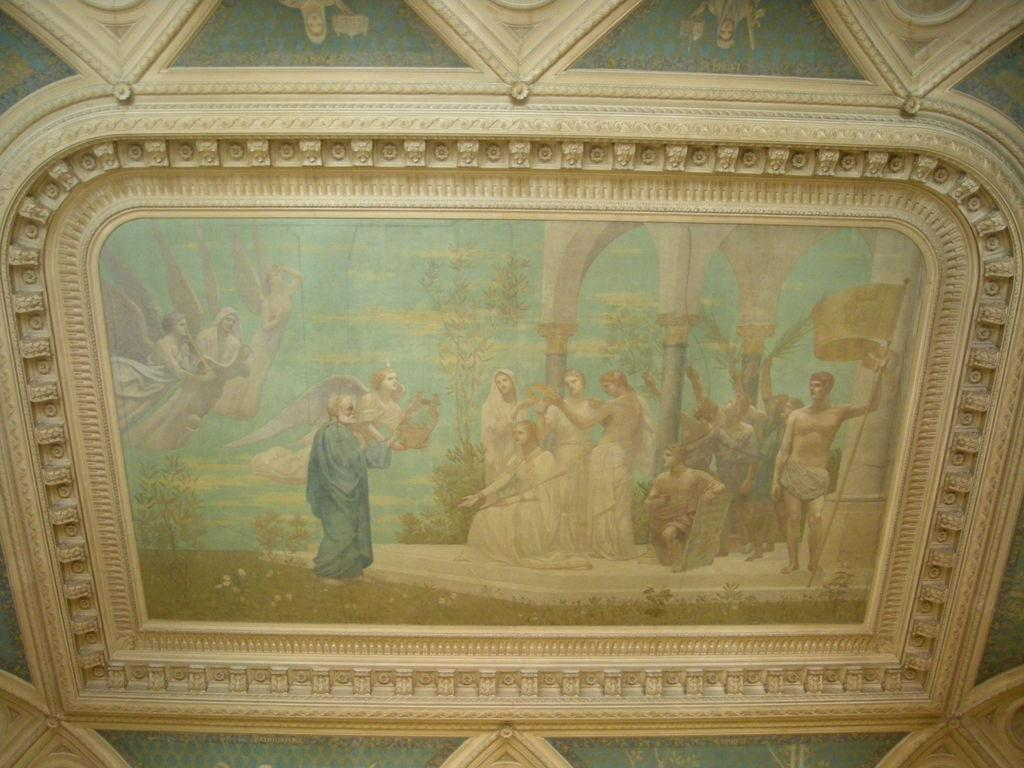What is depicted on the wall in the image? There is a painting on the wall in the image. What elements are included in the painting? The painting contains many people, trees, and a water body. Are there any additional design elements on the wall in the image? Yes, there are designs on the wall in the image. Can you tell me how many grapes are in the painting? There are no grapes present in the painting; it features people, trees, and a water body. What type of berry can be seen growing near the airport in the image? There is no airport or berry present in the image; it only contains a painting on the wall. 